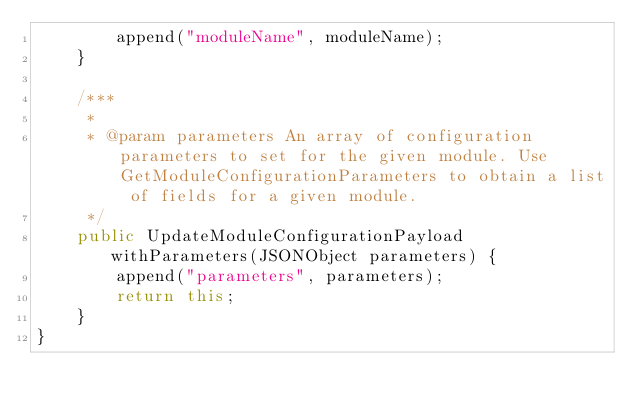<code> <loc_0><loc_0><loc_500><loc_500><_Java_>        append("moduleName", moduleName);
    }

    /***
     *
     * @param parameters An array of configuration parameters to set for the given module. Use GetModuleConfigurationParameters to obtain a list of fields for a given module.
     */
    public UpdateModuleConfigurationPayload withParameters(JSONObject parameters) {
        append("parameters", parameters);
        return this;
    }
}
</code> 